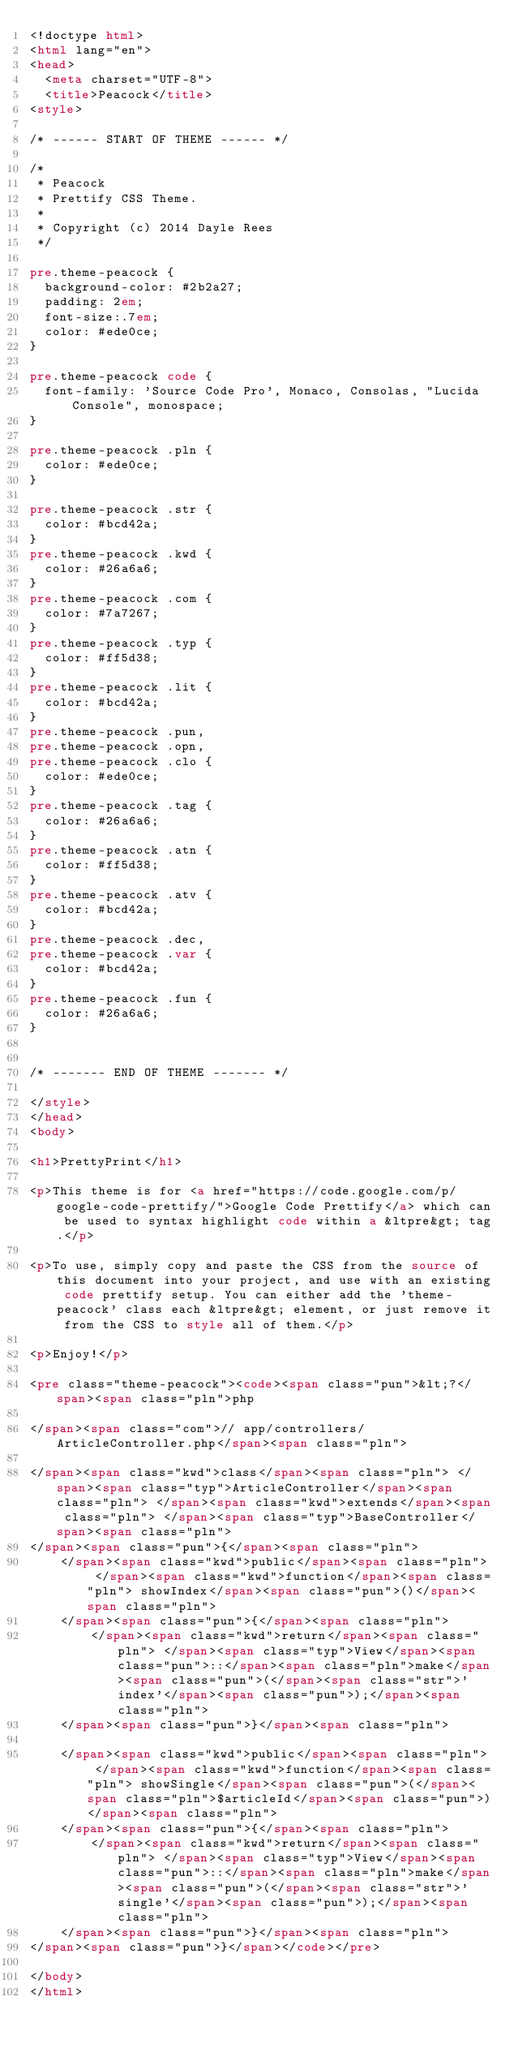<code> <loc_0><loc_0><loc_500><loc_500><_HTML_><!doctype html>
<html lang="en">
<head>
  <meta charset="UTF-8">
  <title>Peacock</title>
<style>

/* ------ START OF THEME ------ */

/*
 * Peacock
 * Prettify CSS Theme.
 *
 * Copyright (c) 2014 Dayle Rees
 */

pre.theme-peacock {
  background-color: #2b2a27;
  padding: 2em;
  font-size:.7em;
  color: #ede0ce;
}

pre.theme-peacock code {
  font-family: 'Source Code Pro', Monaco, Consolas, "Lucida Console", monospace;
}

pre.theme-peacock .pln {
  color: #ede0ce;
}

pre.theme-peacock .str {
  color: #bcd42a;
}
pre.theme-peacock .kwd {
  color: #26a6a6;
}
pre.theme-peacock .com {
  color: #7a7267;
}
pre.theme-peacock .typ {
  color: #ff5d38;
}
pre.theme-peacock .lit {
  color: #bcd42a;
}
pre.theme-peacock .pun,
pre.theme-peacock .opn,
pre.theme-peacock .clo {
  color: #ede0ce;
}
pre.theme-peacock .tag {
  color: #26a6a6;
}
pre.theme-peacock .atn {
  color: #ff5d38;
}
pre.theme-peacock .atv {
  color: #bcd42a;
}
pre.theme-peacock .dec,
pre.theme-peacock .var {
  color: #bcd42a;
}
pre.theme-peacock .fun {
  color: #26a6a6;
}


/* ------- END OF THEME ------- */

</style>
</head>
<body>

<h1>PrettyPrint</h1>

<p>This theme is for <a href="https://code.google.com/p/google-code-prettify/">Google Code Prettify</a> which can be used to syntax highlight code within a &ltpre&gt; tag.</p>

<p>To use, simply copy and paste the CSS from the source of this document into your project, and use with an existing code prettify setup. You can either add the 'theme-peacock' class each &ltpre&gt; element, or just remove it from the CSS to style all of them.</p>

<p>Enjoy!</p>

<pre class="theme-peacock"><code><span class="pun">&lt;?</span><span class="pln">php

</span><span class="com">// app/controllers/ArticleController.php</span><span class="pln">

</span><span class="kwd">class</span><span class="pln"> </span><span class="typ">ArticleController</span><span class="pln"> </span><span class="kwd">extends</span><span class="pln"> </span><span class="typ">BaseController</span><span class="pln">
</span><span class="pun">{</span><span class="pln">
    </span><span class="kwd">public</span><span class="pln"> </span><span class="kwd">function</span><span class="pln"> showIndex</span><span class="pun">()</span><span class="pln">
    </span><span class="pun">{</span><span class="pln">
        </span><span class="kwd">return</span><span class="pln"> </span><span class="typ">View</span><span class="pun">::</span><span class="pln">make</span><span class="pun">(</span><span class="str">'index'</span><span class="pun">);</span><span class="pln">
    </span><span class="pun">}</span><span class="pln">

    </span><span class="kwd">public</span><span class="pln"> </span><span class="kwd">function</span><span class="pln"> showSingle</span><span class="pun">(</span><span class="pln">$articleId</span><span class="pun">)</span><span class="pln">
    </span><span class="pun">{</span><span class="pln">
        </span><span class="kwd">return</span><span class="pln"> </span><span class="typ">View</span><span class="pun">::</span><span class="pln">make</span><span class="pun">(</span><span class="str">'single'</span><span class="pun">);</span><span class="pln">
    </span><span class="pun">}</span><span class="pln">
</span><span class="pun">}</span></code></pre>

</body>
</html>

</code> 